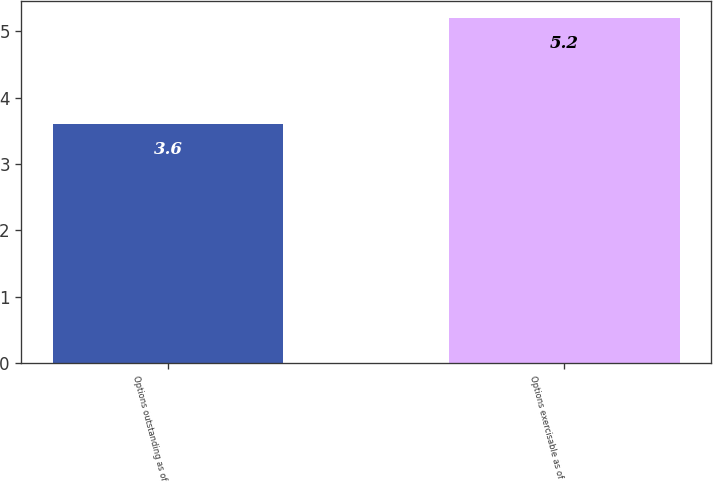Convert chart to OTSL. <chart><loc_0><loc_0><loc_500><loc_500><bar_chart><fcel>Options outstanding as of<fcel>Options exercisable as of<nl><fcel>3.6<fcel>5.2<nl></chart> 